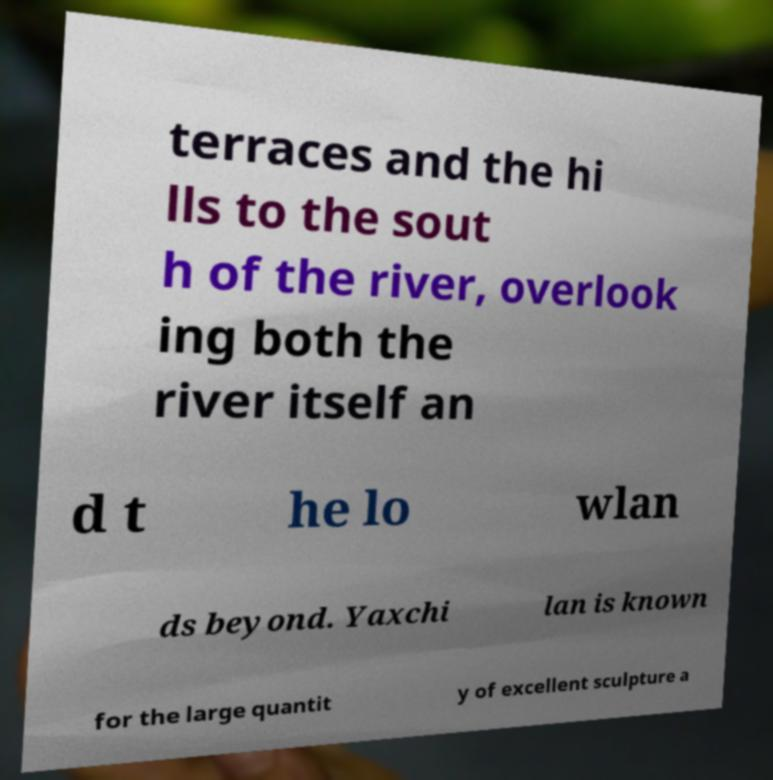Please identify and transcribe the text found in this image. terraces and the hi lls to the sout h of the river, overlook ing both the river itself an d t he lo wlan ds beyond. Yaxchi lan is known for the large quantit y of excellent sculpture a 